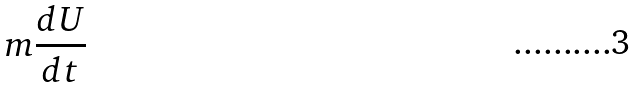<formula> <loc_0><loc_0><loc_500><loc_500>m \frac { d U } { d t }</formula> 